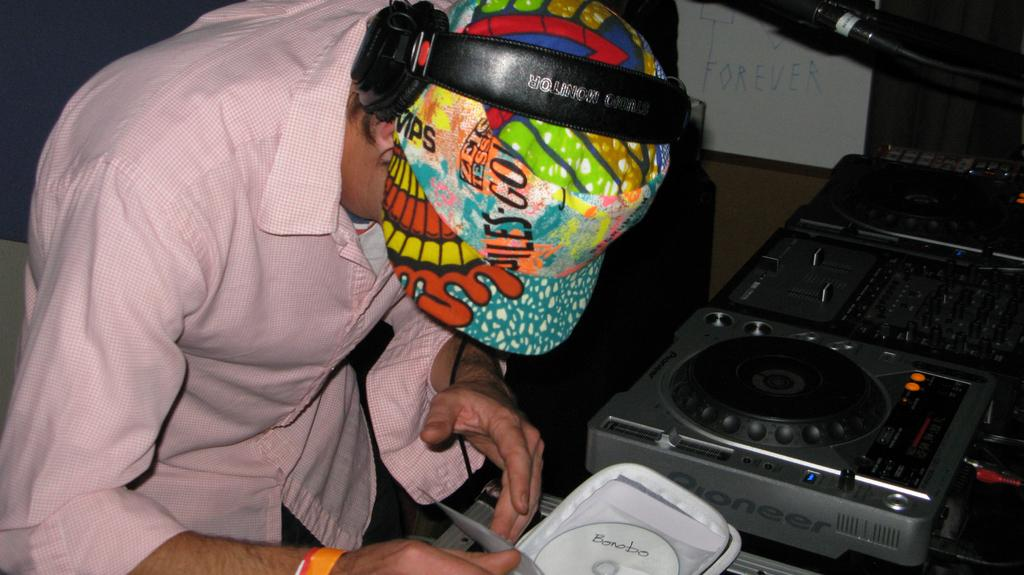What can be seen in the image related to a person? There is a person in the image, and they are wearing headphones and a cap. What is the person holding in the image? The person is holding a bag in the image. What is inside the bag? There is a CD in the bag. What device is related to music in the image? There is a music player in the image. What can be seen on a surface in the image? There is a whiteboard with text in the image. How would you describe the overall lighting in the image? The background of the image is dark. What type of ornament is hanging from the person's toe in the image? There is no ornament hanging from the person's toe in the image, as they are wearing a cap and headphones but not any visible ornaments. 